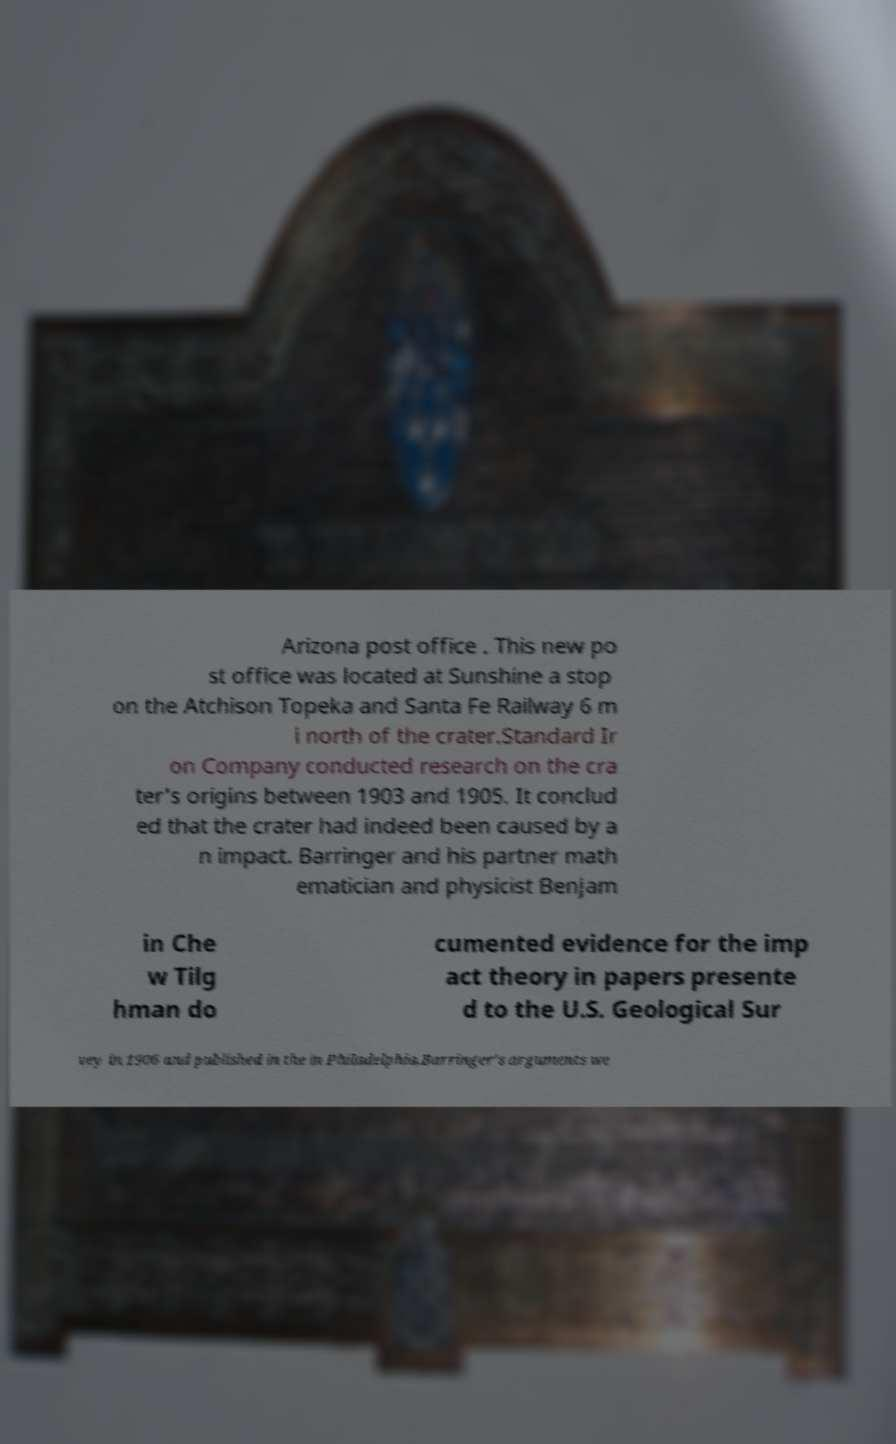Can you accurately transcribe the text from the provided image for me? Arizona post office . This new po st office was located at Sunshine a stop on the Atchison Topeka and Santa Fe Railway 6 m i north of the crater.Standard Ir on Company conducted research on the cra ter's origins between 1903 and 1905. It conclud ed that the crater had indeed been caused by a n impact. Barringer and his partner math ematician and physicist Benjam in Che w Tilg hman do cumented evidence for the imp act theory in papers presente d to the U.S. Geological Sur vey in 1906 and published in the in Philadelphia.Barringer's arguments we 